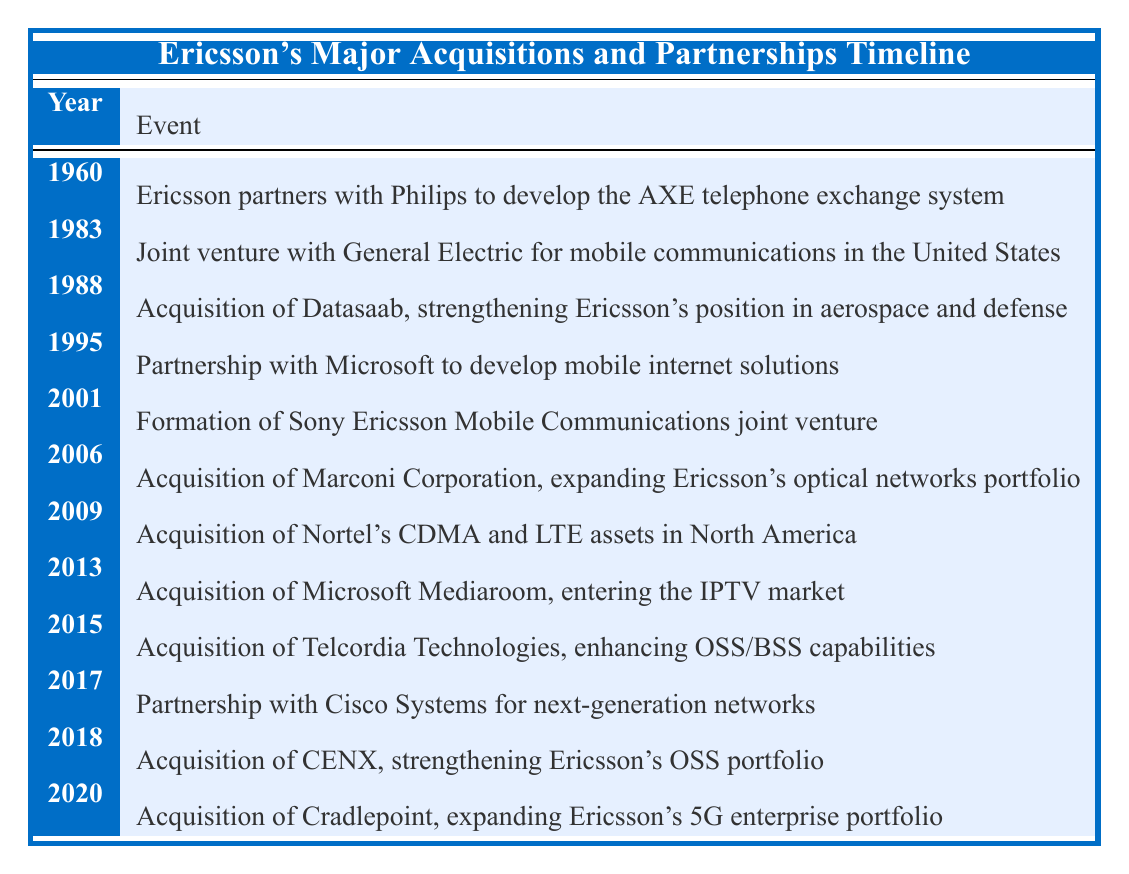What year did Ericsson acquire Datasaab? The table indicates that the acquisition of Datasaab took place in the year 1988.
Answer: 1988 What major event occurred in 2001 for Ericsson? In 2001, Ericsson formed a joint venture called Sony Ericsson Mobile Communications.
Answer: Formation of Sony Ericsson Mobile Communications How many partnerships or acquisitions are listed from 1960 to 2000? By counting the events in the timeline from 1960 up to the year 2000, there are four events: one in 1960, one in 1983, one in 1995, and one in 2001, but the last is counted for the early part of 2001.
Answer: 4 Is the acquisition of Nortel’s assets occurring before or after the partnership with Cisco Systems? The acquisition of Nortel’s assets happened in 2009, while the partnership with Cisco Systems occurred in 2017; therefore, the acquisition happened before the partnership.
Answer: Before What are the total number of acquisitions listed in the timeline? If we count the events labeled as acquisitions in the timeline, we have five in total. They are from the years 1988, 2006, 2009, 2013, 2015, and 2018.
Answer: 6 Which acquisition expanded Ericsson's 5G enterprise portfolio? The acquisition that expanded Ericsson's 5G enterprise portfolio, according to the table, was the acquisition of Cradlepoint in the year 2020.
Answer: Acquisition of Cradlepoint What is the difference in years between the partnership with Microsoft and the acquisition of Telcordia Technologies? The partnership with Microsoft happened in 1995, and the acquisition of Telcordia Technologies occurred in 2015. The difference in years is 2015 - 1995 = 20 years.
Answer: 20 years Did Ericsson's partnership with General Electric happen in the 1980s? Yes, the partnership with General Electric for mobile communications took place in 1983, which is indeed in the 1980s.
Answer: Yes Which event indicates a significant entry into the IPTV market? The table shows that the acquisition of Microsoft Mediaroom in 2013 marks Ericsson's significant entry into the IPTV market.
Answer: Acquisition of Microsoft Mediaroom 